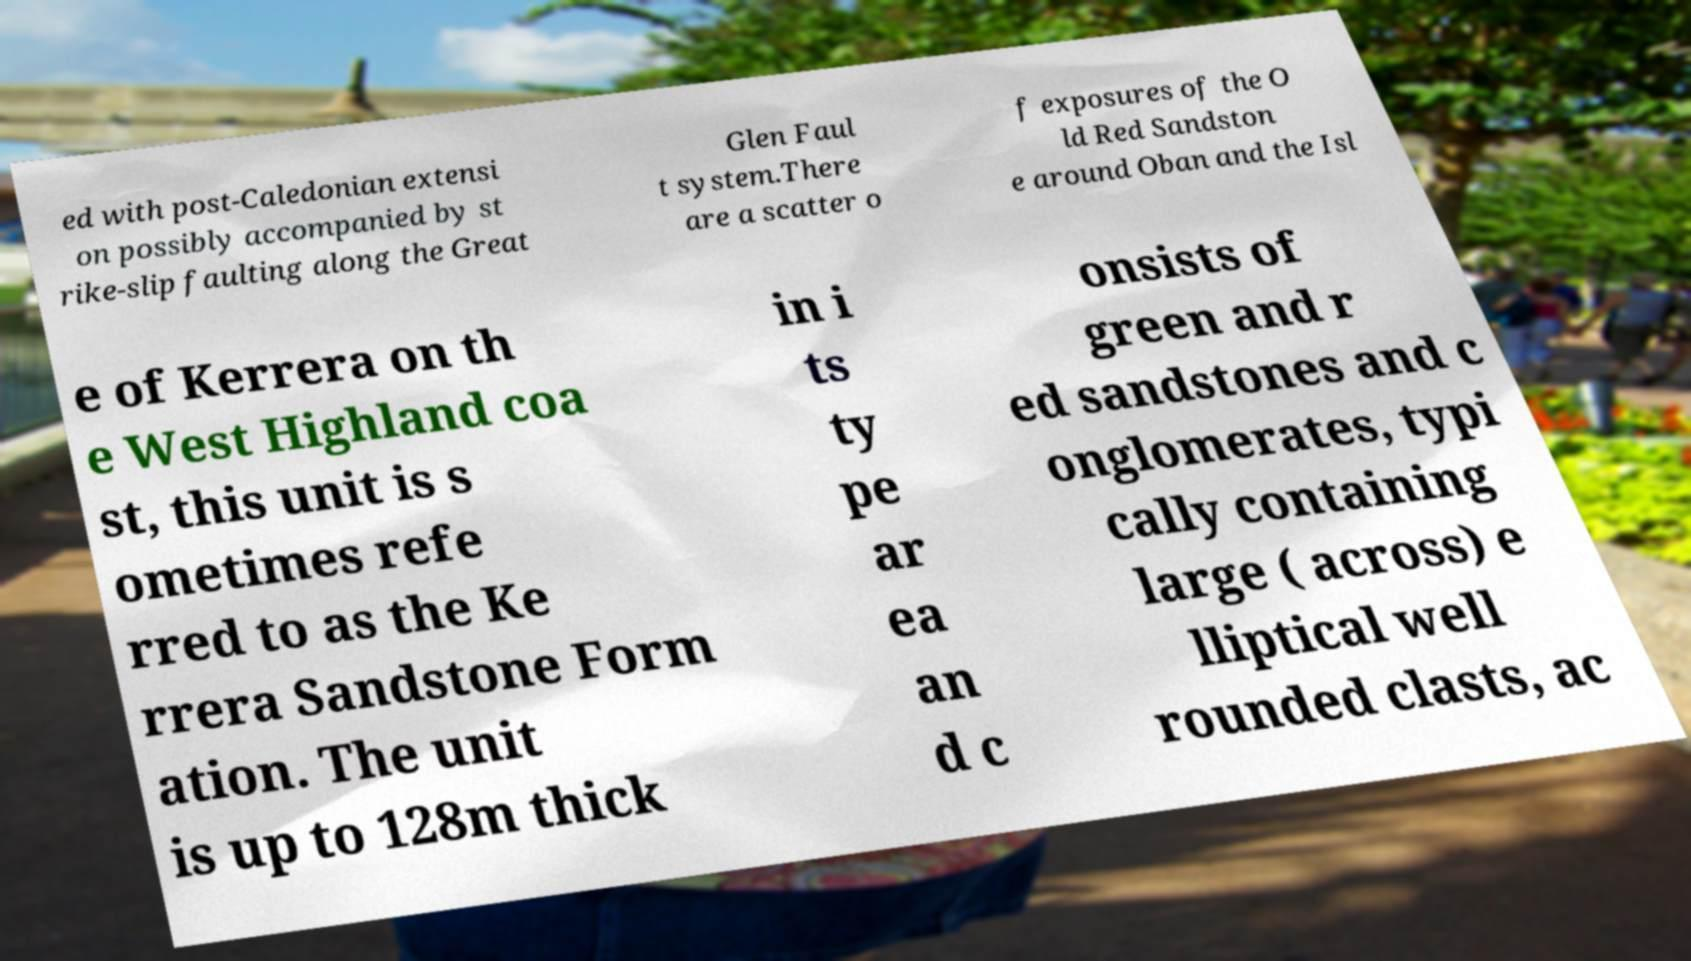Can you read and provide the text displayed in the image?This photo seems to have some interesting text. Can you extract and type it out for me? ed with post-Caledonian extensi on possibly accompanied by st rike-slip faulting along the Great Glen Faul t system.There are a scatter o f exposures of the O ld Red Sandston e around Oban and the Isl e of Kerrera on th e West Highland coa st, this unit is s ometimes refe rred to as the Ke rrera Sandstone Form ation. The unit is up to 128m thick in i ts ty pe ar ea an d c onsists of green and r ed sandstones and c onglomerates, typi cally containing large ( across) e lliptical well rounded clasts, ac 